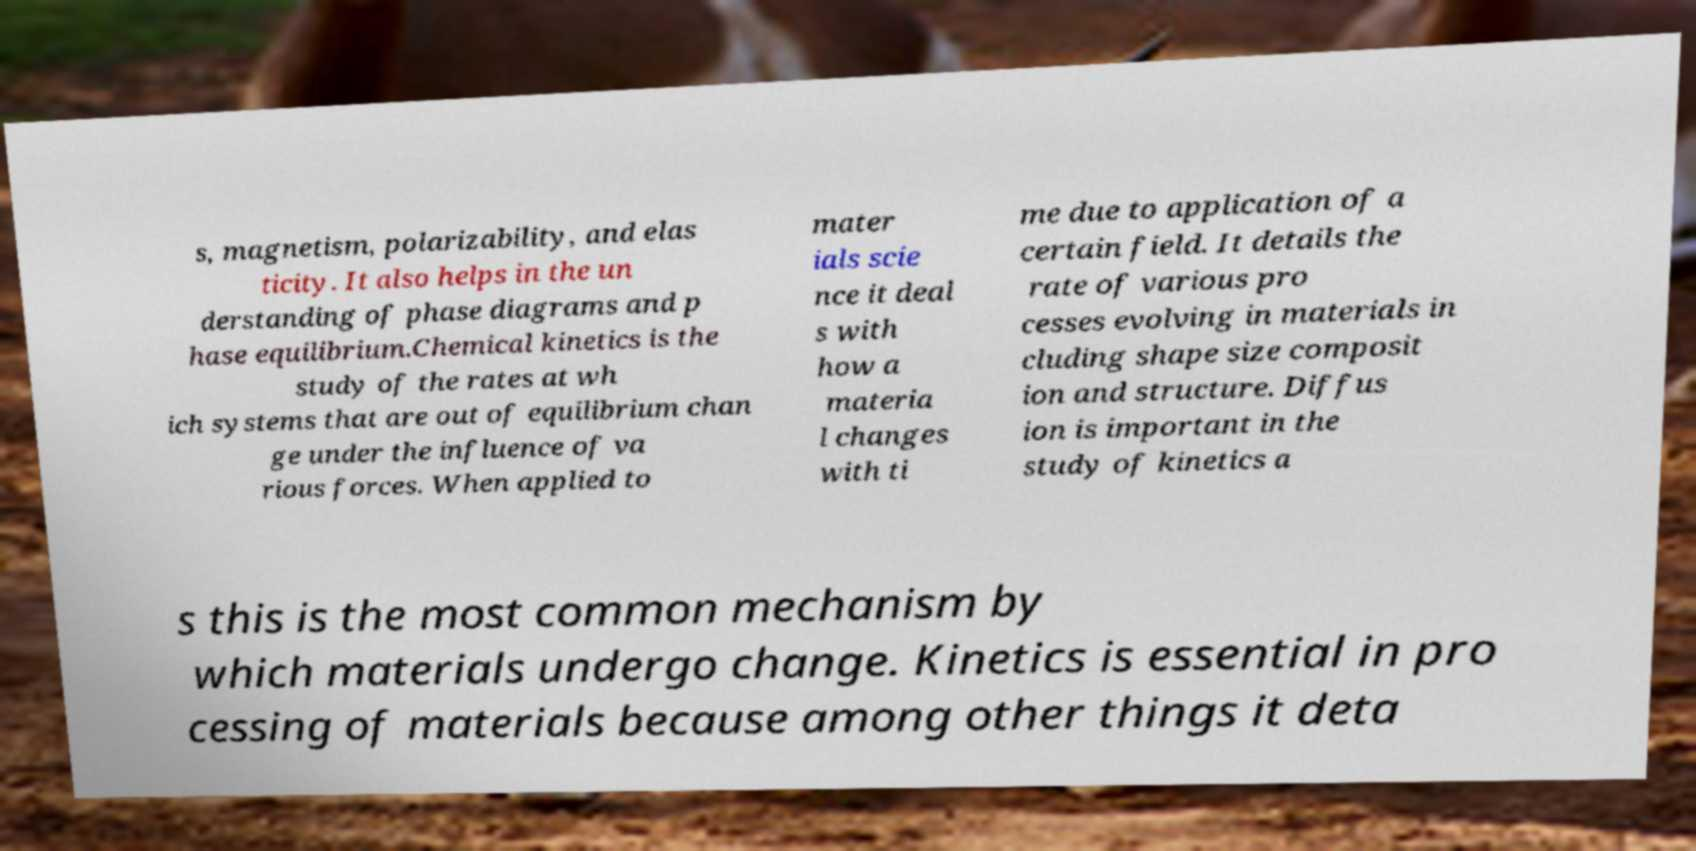Please read and relay the text visible in this image. What does it say? s, magnetism, polarizability, and elas ticity. It also helps in the un derstanding of phase diagrams and p hase equilibrium.Chemical kinetics is the study of the rates at wh ich systems that are out of equilibrium chan ge under the influence of va rious forces. When applied to mater ials scie nce it deal s with how a materia l changes with ti me due to application of a certain field. It details the rate of various pro cesses evolving in materials in cluding shape size composit ion and structure. Diffus ion is important in the study of kinetics a s this is the most common mechanism by which materials undergo change. Kinetics is essential in pro cessing of materials because among other things it deta 